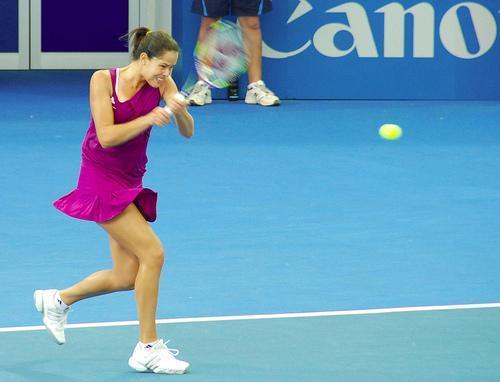How many players are seen?
Give a very brief answer. 1. 